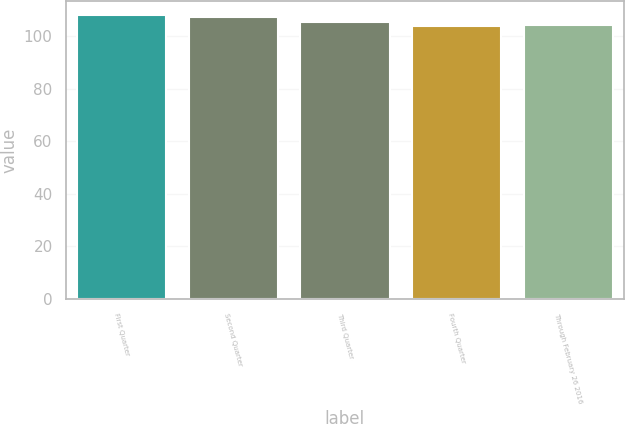Convert chart. <chart><loc_0><loc_0><loc_500><loc_500><bar_chart><fcel>First Quarter<fcel>Second Quarter<fcel>Third Quarter<fcel>Fourth Quarter<fcel>Through February 26 2016<nl><fcel>107.87<fcel>107.21<fcel>105.46<fcel>103.6<fcel>104.11<nl></chart> 